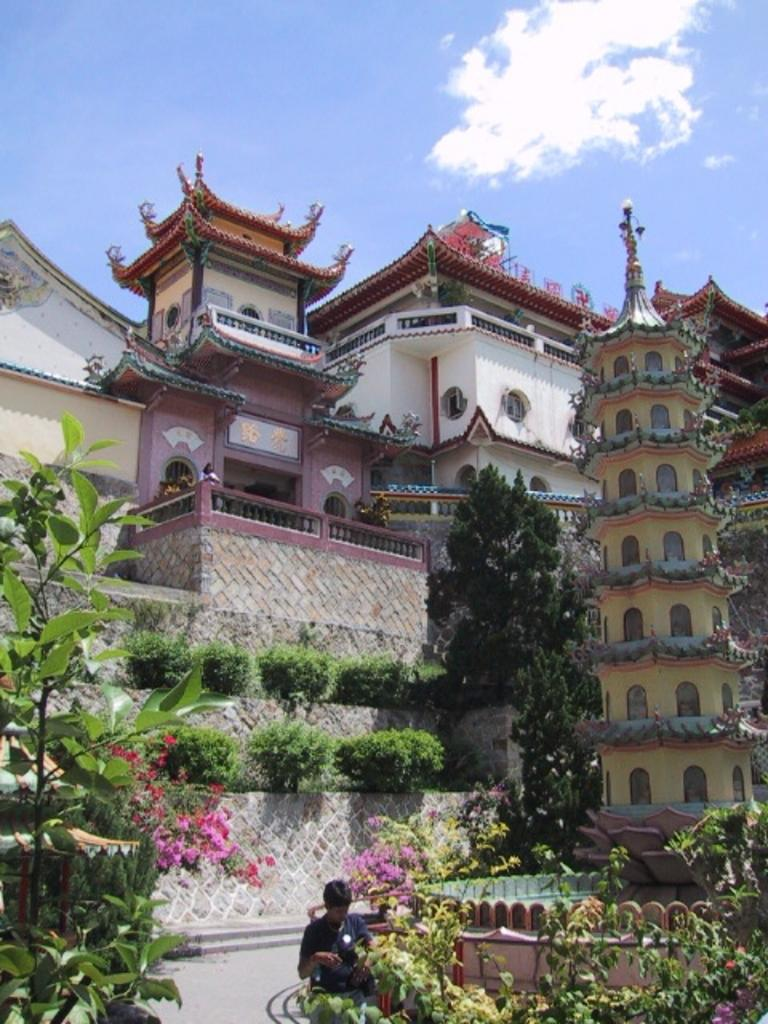What type of structures can be seen in the image? There are many buildings in the image. What is located in front of the buildings? There are plants and trees in front of the buildings. Can you describe the person in the image? There is a person standing in front of one of the trees. What type of selection process is being conducted by the trees in the image? There is no indication of a selection process being conducted by the trees in the image; they are simply standing in front of the buildings. 